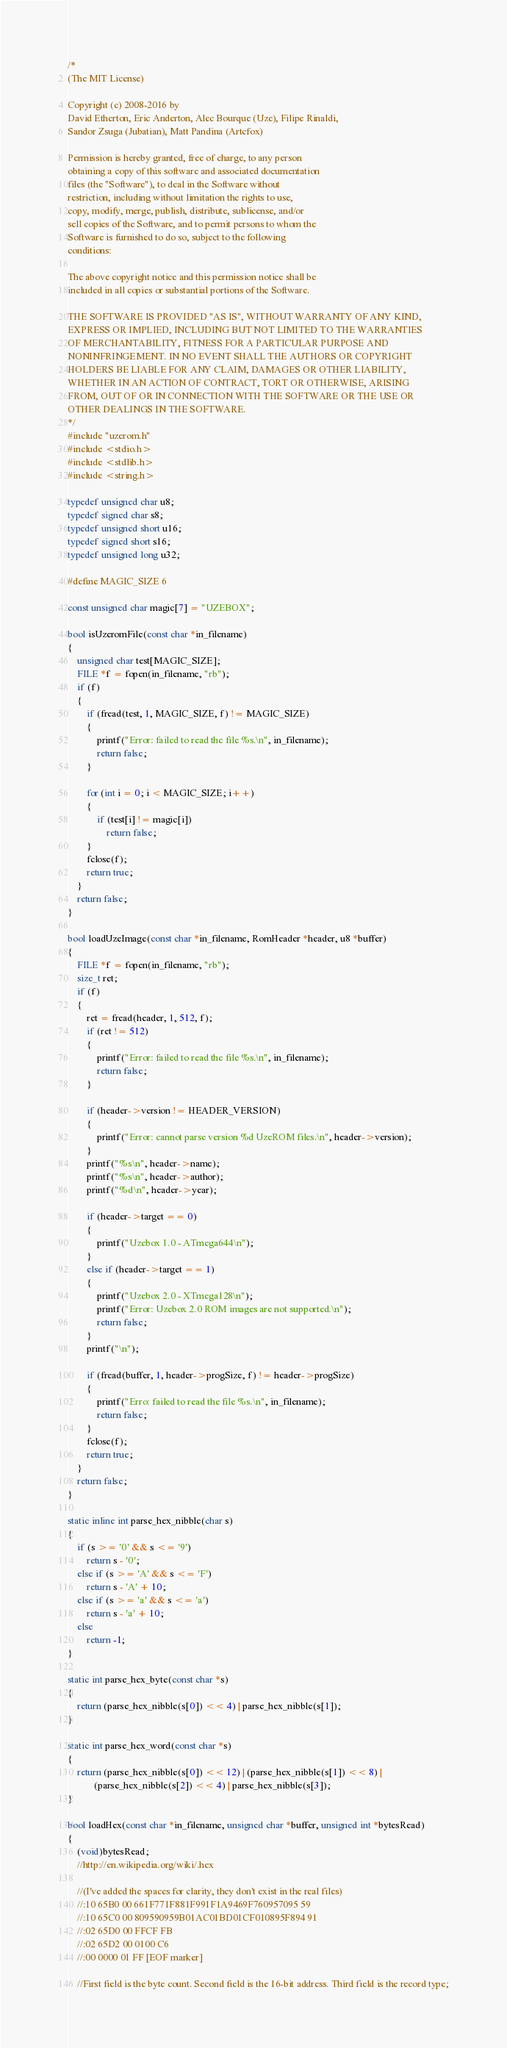Convert code to text. <code><loc_0><loc_0><loc_500><loc_500><_C++_>/*
(The MIT License)

Copyright (c) 2008-2016 by
David Etherton, Eric Anderton, Alec Bourque (Uze), Filipe Rinaldi,
Sandor Zsuga (Jubatian), Matt Pandina (Artcfox)
        
Permission is hereby granted, free of charge, to any person
obtaining a copy of this software and associated documentation
files (the "Software"), to deal in the Software without
restriction, including without limitation the rights to use,
copy, modify, merge, publish, distribute, sublicense, and/or
sell copies of the Software, and to permit persons to whom the
Software is furnished to do so, subject to the following
conditions:

The above copyright notice and this permission notice shall be
included in all copies or substantial portions of the Software.

THE SOFTWARE IS PROVIDED "AS IS", WITHOUT WARRANTY OF ANY KIND,
EXPRESS OR IMPLIED, INCLUDING BUT NOT LIMITED TO THE WARRANTIES
OF MERCHANTABILITY, FITNESS FOR A PARTICULAR PURPOSE AND
NONINFRINGEMENT. IN NO EVENT SHALL THE AUTHORS OR COPYRIGHT
HOLDERS BE LIABLE FOR ANY CLAIM, DAMAGES OR OTHER LIABILITY,
WHETHER IN AN ACTION OF CONTRACT, TORT OR OTHERWISE, ARISING
FROM, OUT OF OR IN CONNECTION WITH THE SOFTWARE OR THE USE OR
OTHER DEALINGS IN THE SOFTWARE.
*/
#include "uzerom.h"
#include <stdio.h>
#include <stdlib.h>
#include <string.h>

typedef unsigned char u8;
typedef signed char s8;
typedef unsigned short u16;
typedef signed short s16;
typedef unsigned long u32;

#define MAGIC_SIZE 6

const unsigned char magic[7] = "UZEBOX";

bool isUzeromFile(const char *in_filename)
{
	unsigned char test[MAGIC_SIZE];
	FILE *f = fopen(in_filename, "rb");
	if (f)
	{
		if (fread(test, 1, MAGIC_SIZE, f) != MAGIC_SIZE)
		{
			printf("Error: failed to read the file %s.\n", in_filename);
			return false;
		}

		for (int i = 0; i < MAGIC_SIZE; i++)
		{
			if (test[i] != magic[i])
				return false;
		}
		fclose(f);
		return true;
	}
	return false;
}

bool loadUzeImage(const char *in_filename, RomHeader *header, u8 *buffer)
{
	FILE *f = fopen(in_filename, "rb");
	size_t ret;
	if (f)
	{
		ret = fread(header, 1, 512, f);
		if (ret != 512)
		{
			printf("Error: failed to read the file %s.\n", in_filename);
			return false;
		}

		if (header->version != HEADER_VERSION)
		{
			printf("Error: cannot parse version %d UzeROM files.\n", header->version);
		}
		printf("%s\n", header->name);
		printf("%s\n", header->author);
		printf("%d\n", header->year);

		if (header->target == 0)
		{
			printf("Uzebox 1.0 - ATmega644\n");
		}
		else if (header->target == 1)
		{
			printf("Uzebox 2.0 - XTmega128\n");
			printf("Error: Uzebox 2.0 ROM images are not supported.\n");
			return false;
		}
		printf("\n");

		if (fread(buffer, 1, header->progSize, f) != header->progSize)
		{
			printf("Erro: failed to read the file %s.\n", in_filename);
			return false;
		}
		fclose(f);
		return true;
	}
	return false;
}

static inline int parse_hex_nibble(char s)
{
	if (s >= '0' && s <= '9')
		return s - '0';
	else if (s >= 'A' && s <= 'F')
		return s - 'A' + 10;
	else if (s >= 'a' && s <= 'a')
		return s - 'a' + 10;
	else
		return -1;
}

static int parse_hex_byte(const char *s)
{
	return (parse_hex_nibble(s[0]) << 4) | parse_hex_nibble(s[1]);
}

static int parse_hex_word(const char *s)
{
	return (parse_hex_nibble(s[0]) << 12) | (parse_hex_nibble(s[1]) << 8) |
		   (parse_hex_nibble(s[2]) << 4) | parse_hex_nibble(s[3]);
}

bool loadHex(const char *in_filename, unsigned char *buffer, unsigned int *bytesRead)
{
	(void)bytesRead;
	//http://en.wikipedia.org/wiki/.hex

	//(I've added the spaces for clarity, they don't exist in the real files)
	//:10 65B0 00 661F771F881F991F1A9469F760957095 59
	//:10 65C0 00 809590959B01AC01BD01CF010895F894 91
	//:02 65D0 00 FFCF FB
	//:02 65D2 00 0100 C6
	//:00 0000 01 FF [EOF marker]

	//First field is the byte count. Second field is the 16-bit address. Third field is the record type;</code> 